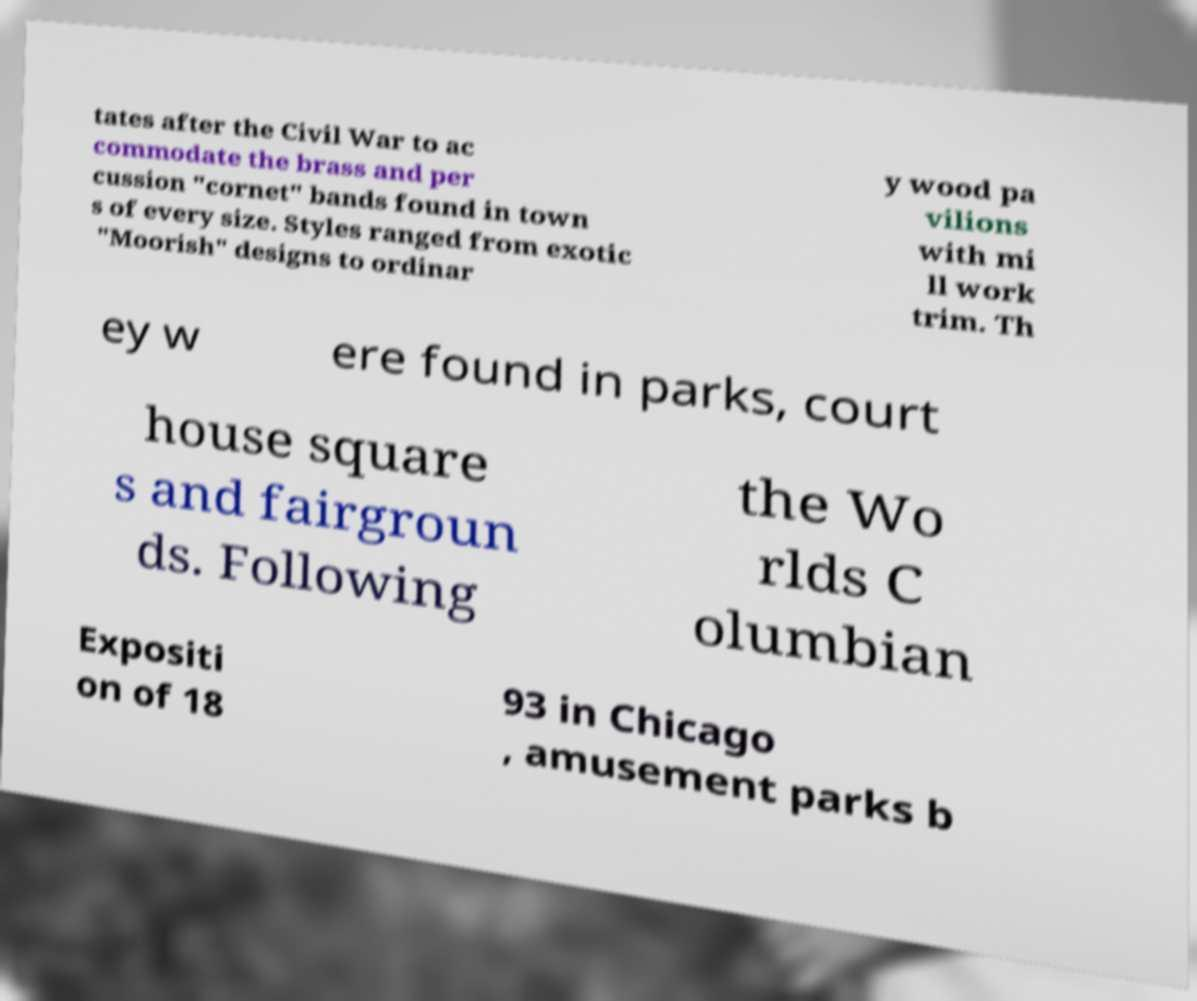Could you assist in decoding the text presented in this image and type it out clearly? tates after the Civil War to ac commodate the brass and per cussion ″cornet″ bands found in town s of every size. Styles ranged from exotic ″Moorish″ designs to ordinar y wood pa vilions with mi ll work trim. Th ey w ere found in parks, court house square s and fairgroun ds. Following the Wo rlds C olumbian Expositi on of 18 93 in Chicago , amusement parks b 